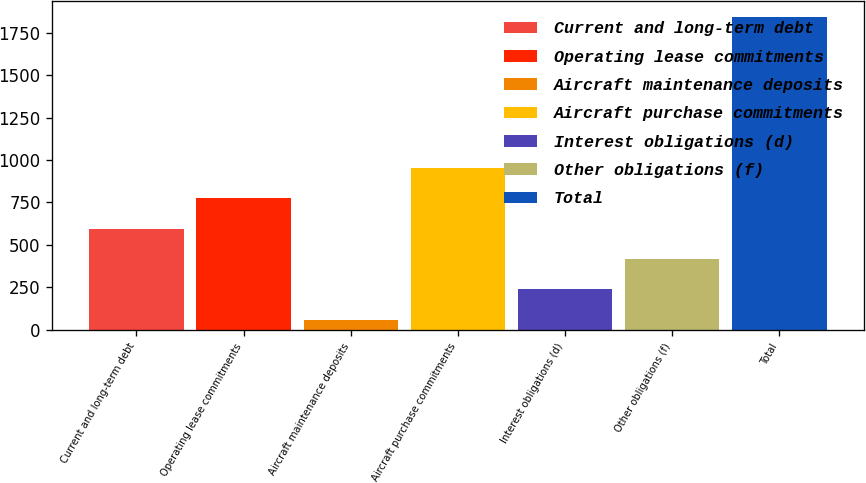Convert chart. <chart><loc_0><loc_0><loc_500><loc_500><bar_chart><fcel>Current and long-term debt<fcel>Operating lease commitments<fcel>Aircraft maintenance deposits<fcel>Aircraft purchase commitments<fcel>Interest obligations (d)<fcel>Other obligations (f)<fcel>Total<nl><fcel>595.6<fcel>773.8<fcel>61<fcel>952<fcel>239.2<fcel>417.4<fcel>1843<nl></chart> 